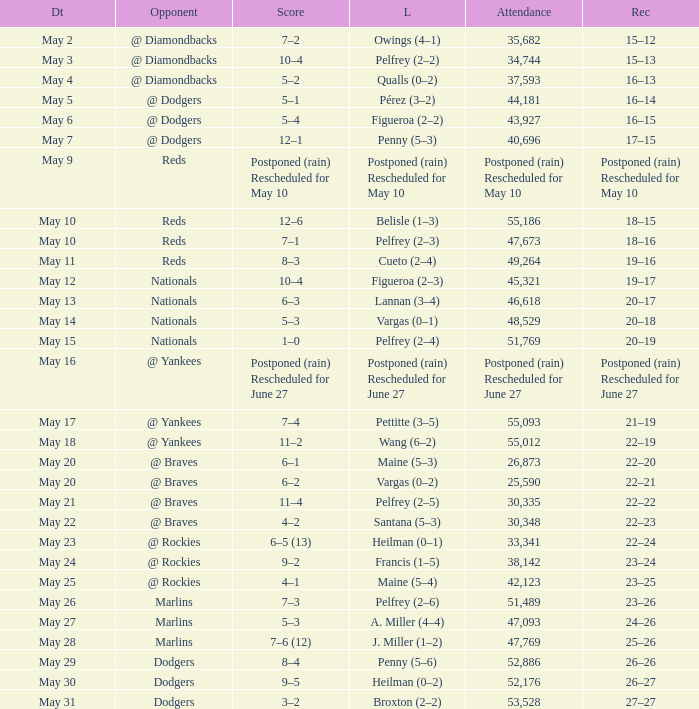Parse the full table. {'header': ['Dt', 'Opponent', 'Score', 'L', 'Attendance', 'Rec'], 'rows': [['May 2', '@ Diamondbacks', '7–2', 'Owings (4–1)', '35,682', '15–12'], ['May 3', '@ Diamondbacks', '10–4', 'Pelfrey (2–2)', '34,744', '15–13'], ['May 4', '@ Diamondbacks', '5–2', 'Qualls (0–2)', '37,593', '16–13'], ['May 5', '@ Dodgers', '5–1', 'Pérez (3–2)', '44,181', '16–14'], ['May 6', '@ Dodgers', '5–4', 'Figueroa (2–2)', '43,927', '16–15'], ['May 7', '@ Dodgers', '12–1', 'Penny (5–3)', '40,696', '17–15'], ['May 9', 'Reds', 'Postponed (rain) Rescheduled for May 10', 'Postponed (rain) Rescheduled for May 10', 'Postponed (rain) Rescheduled for May 10', 'Postponed (rain) Rescheduled for May 10'], ['May 10', 'Reds', '12–6', 'Belisle (1–3)', '55,186', '18–15'], ['May 10', 'Reds', '7–1', 'Pelfrey (2–3)', '47,673', '18–16'], ['May 11', 'Reds', '8–3', 'Cueto (2–4)', '49,264', '19–16'], ['May 12', 'Nationals', '10–4', 'Figueroa (2–3)', '45,321', '19–17'], ['May 13', 'Nationals', '6–3', 'Lannan (3–4)', '46,618', '20–17'], ['May 14', 'Nationals', '5–3', 'Vargas (0–1)', '48,529', '20–18'], ['May 15', 'Nationals', '1–0', 'Pelfrey (2–4)', '51,769', '20–19'], ['May 16', '@ Yankees', 'Postponed (rain) Rescheduled for June 27', 'Postponed (rain) Rescheduled for June 27', 'Postponed (rain) Rescheduled for June 27', 'Postponed (rain) Rescheduled for June 27'], ['May 17', '@ Yankees', '7–4', 'Pettitte (3–5)', '55,093', '21–19'], ['May 18', '@ Yankees', '11–2', 'Wang (6–2)', '55,012', '22–19'], ['May 20', '@ Braves', '6–1', 'Maine (5–3)', '26,873', '22–20'], ['May 20', '@ Braves', '6–2', 'Vargas (0–2)', '25,590', '22–21'], ['May 21', '@ Braves', '11–4', 'Pelfrey (2–5)', '30,335', '22–22'], ['May 22', '@ Braves', '4–2', 'Santana (5–3)', '30,348', '22–23'], ['May 23', '@ Rockies', '6–5 (13)', 'Heilman (0–1)', '33,341', '22–24'], ['May 24', '@ Rockies', '9–2', 'Francis (1–5)', '38,142', '23–24'], ['May 25', '@ Rockies', '4–1', 'Maine (5–4)', '42,123', '23–25'], ['May 26', 'Marlins', '7–3', 'Pelfrey (2–6)', '51,489', '23–26'], ['May 27', 'Marlins', '5–3', 'A. Miller (4–4)', '47,093', '24–26'], ['May 28', 'Marlins', '7–6 (12)', 'J. Miller (1–2)', '47,769', '25–26'], ['May 29', 'Dodgers', '8–4', 'Penny (5–6)', '52,886', '26–26'], ['May 30', 'Dodgers', '9–5', 'Heilman (0–2)', '52,176', '26–27'], ['May 31', 'Dodgers', '3–2', 'Broxton (2–2)', '53,528', '27–27']]} Record of 22–20 involved what score? 6–1. 